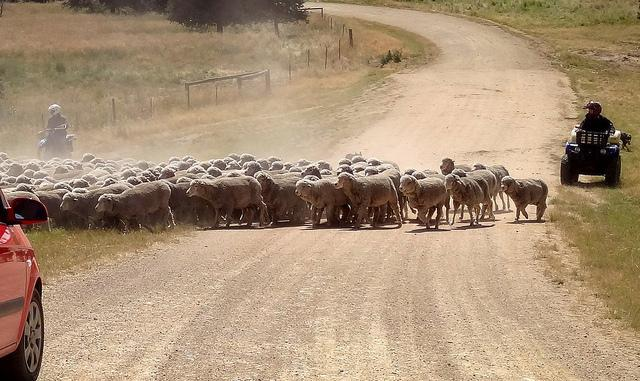Why are the sheep turning right? being herded 